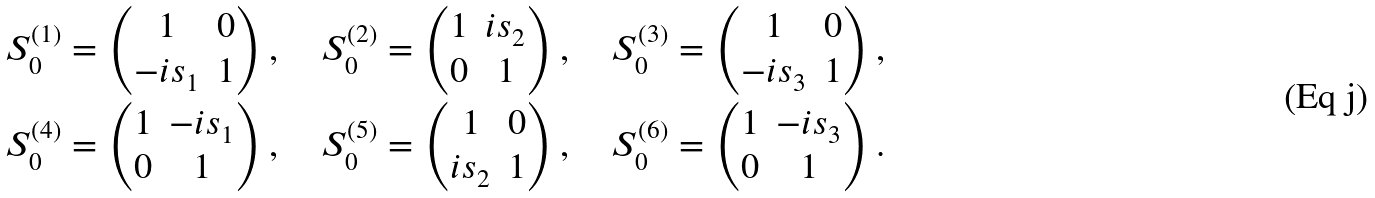<formula> <loc_0><loc_0><loc_500><loc_500>S ^ { ( 1 ) } _ { 0 } = \begin{pmatrix} 1 & 0 \\ - i s _ { 1 } & 1 \end{pmatrix} , \quad S ^ { ( 2 ) } _ { 0 } = \begin{pmatrix} 1 & i s _ { 2 } \\ 0 & 1 \end{pmatrix} , \quad S ^ { ( 3 ) } _ { 0 } = \begin{pmatrix} 1 & 0 \\ - i s _ { 3 } & 1 \end{pmatrix} , \\ S ^ { ( 4 ) } _ { 0 } = \begin{pmatrix} 1 & - i s _ { 1 } \\ 0 & 1 \end{pmatrix} , \quad S ^ { ( 5 ) } _ { 0 } = \begin{pmatrix} 1 & 0 \\ i s _ { 2 } & 1 \end{pmatrix} , \quad S ^ { ( 6 ) } _ { 0 } = \begin{pmatrix} 1 & - i s _ { 3 } \\ 0 & 1 \end{pmatrix} .</formula> 